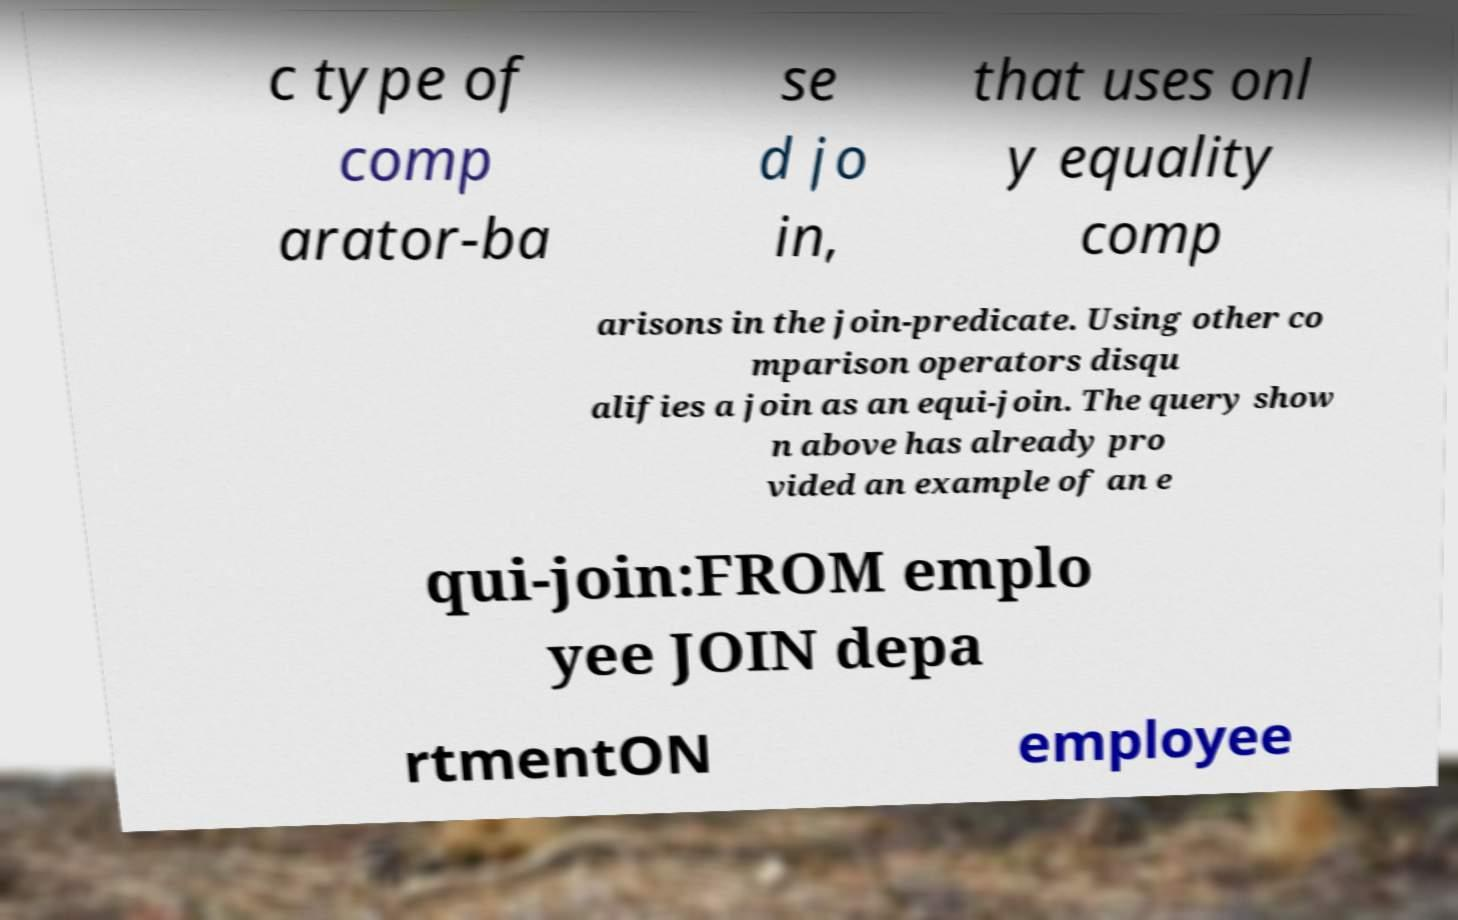Could you assist in decoding the text presented in this image and type it out clearly? c type of comp arator-ba se d jo in, that uses onl y equality comp arisons in the join-predicate. Using other co mparison operators disqu alifies a join as an equi-join. The query show n above has already pro vided an example of an e qui-join:FROM emplo yee JOIN depa rtmentON employee 